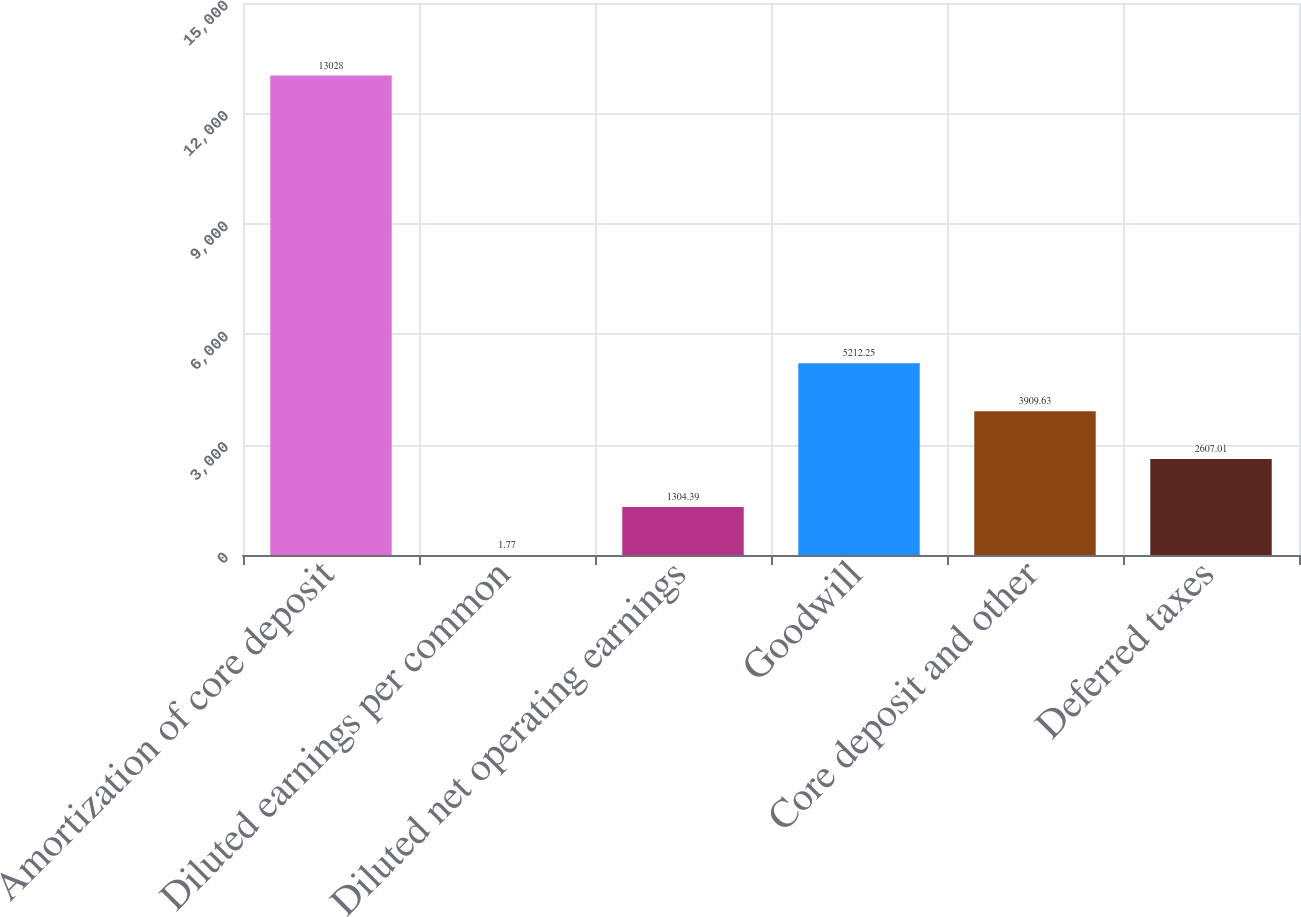Convert chart to OTSL. <chart><loc_0><loc_0><loc_500><loc_500><bar_chart><fcel>Amortization of core deposit<fcel>Diluted earnings per common<fcel>Diluted net operating earnings<fcel>Goodwill<fcel>Core deposit and other<fcel>Deferred taxes<nl><fcel>13028<fcel>1.77<fcel>1304.39<fcel>5212.25<fcel>3909.63<fcel>2607.01<nl></chart> 